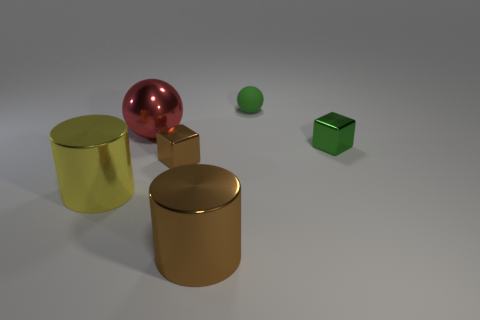Are there fewer small shiny blocks that are to the left of the large metal sphere than red spheres behind the green matte object?
Provide a succinct answer. No. There is a cube that is the same color as the rubber ball; what is it made of?
Keep it short and to the point. Metal. Are there any other things that are the same shape as the large yellow metal thing?
Ensure brevity in your answer.  Yes. There is a thing that is right of the green sphere; what is its material?
Keep it short and to the point. Metal. Is there anything else that has the same size as the yellow metal cylinder?
Make the answer very short. Yes. Are there any small things in front of the small green ball?
Keep it short and to the point. Yes. There is a tiny matte object; what shape is it?
Offer a very short reply. Sphere. How many things are either tiny cubes that are to the right of the small brown block or green shiny spheres?
Your response must be concise. 1. What number of other objects are there of the same color as the matte thing?
Your answer should be very brief. 1. There is a metal ball; is its color the same as the small block that is right of the green matte object?
Offer a very short reply. No. 